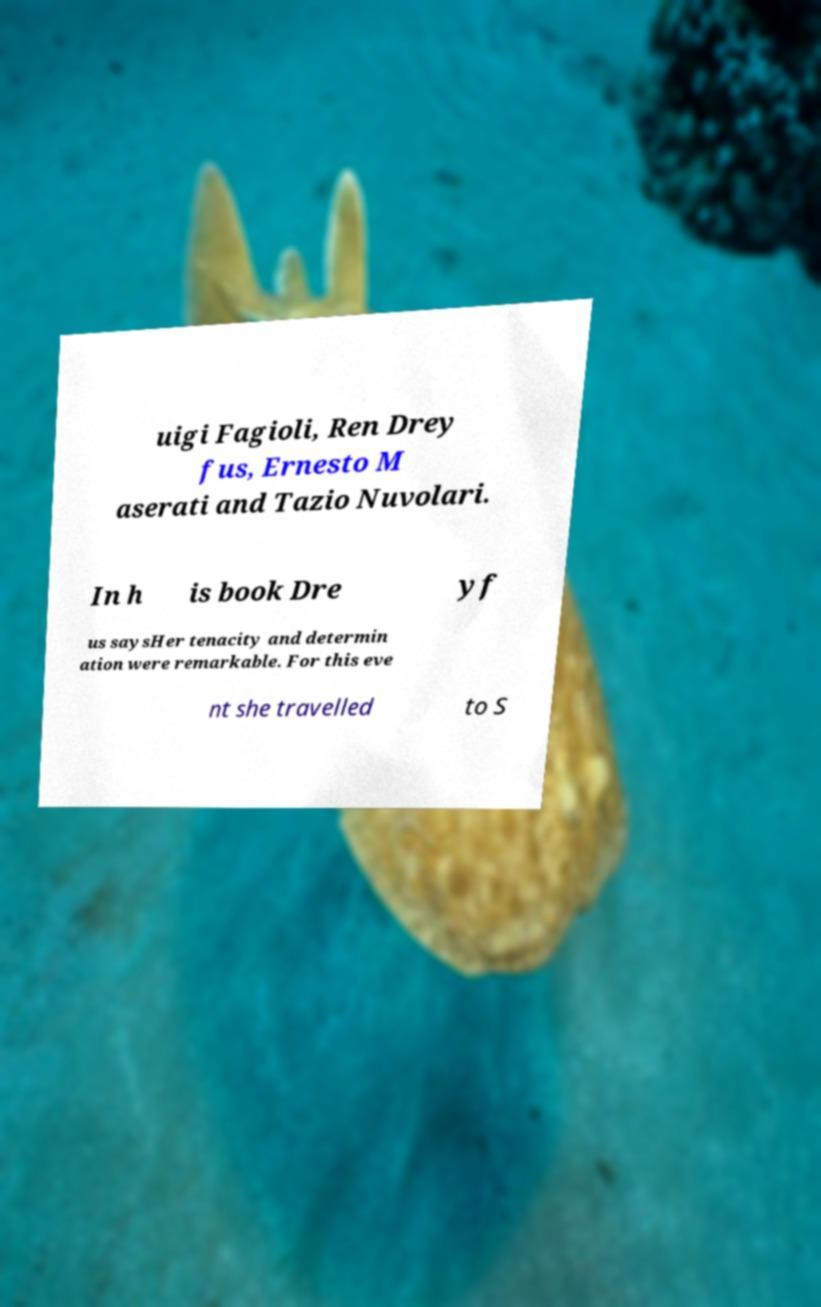There's text embedded in this image that I need extracted. Can you transcribe it verbatim? uigi Fagioli, Ren Drey fus, Ernesto M aserati and Tazio Nuvolari. In h is book Dre yf us saysHer tenacity and determin ation were remarkable. For this eve nt she travelled to S 